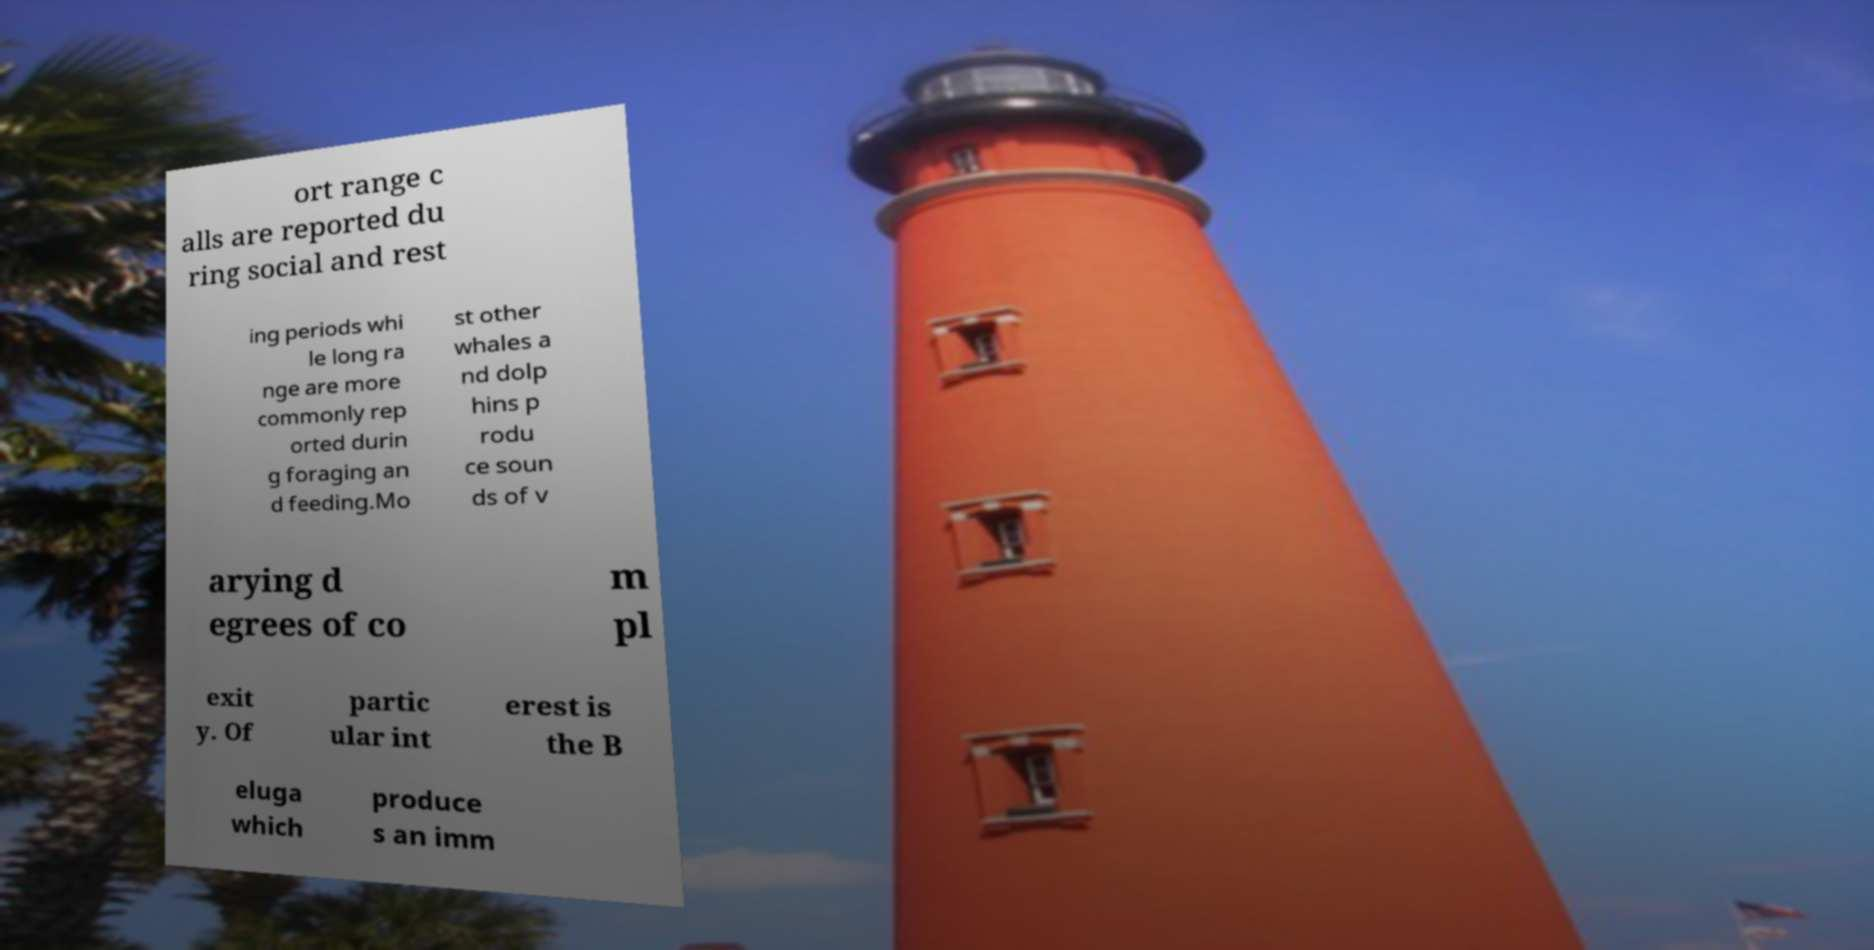Can you accurately transcribe the text from the provided image for me? ort range c alls are reported du ring social and rest ing periods whi le long ra nge are more commonly rep orted durin g foraging an d feeding.Mo st other whales a nd dolp hins p rodu ce soun ds of v arying d egrees of co m pl exit y. Of partic ular int erest is the B eluga which produce s an imm 